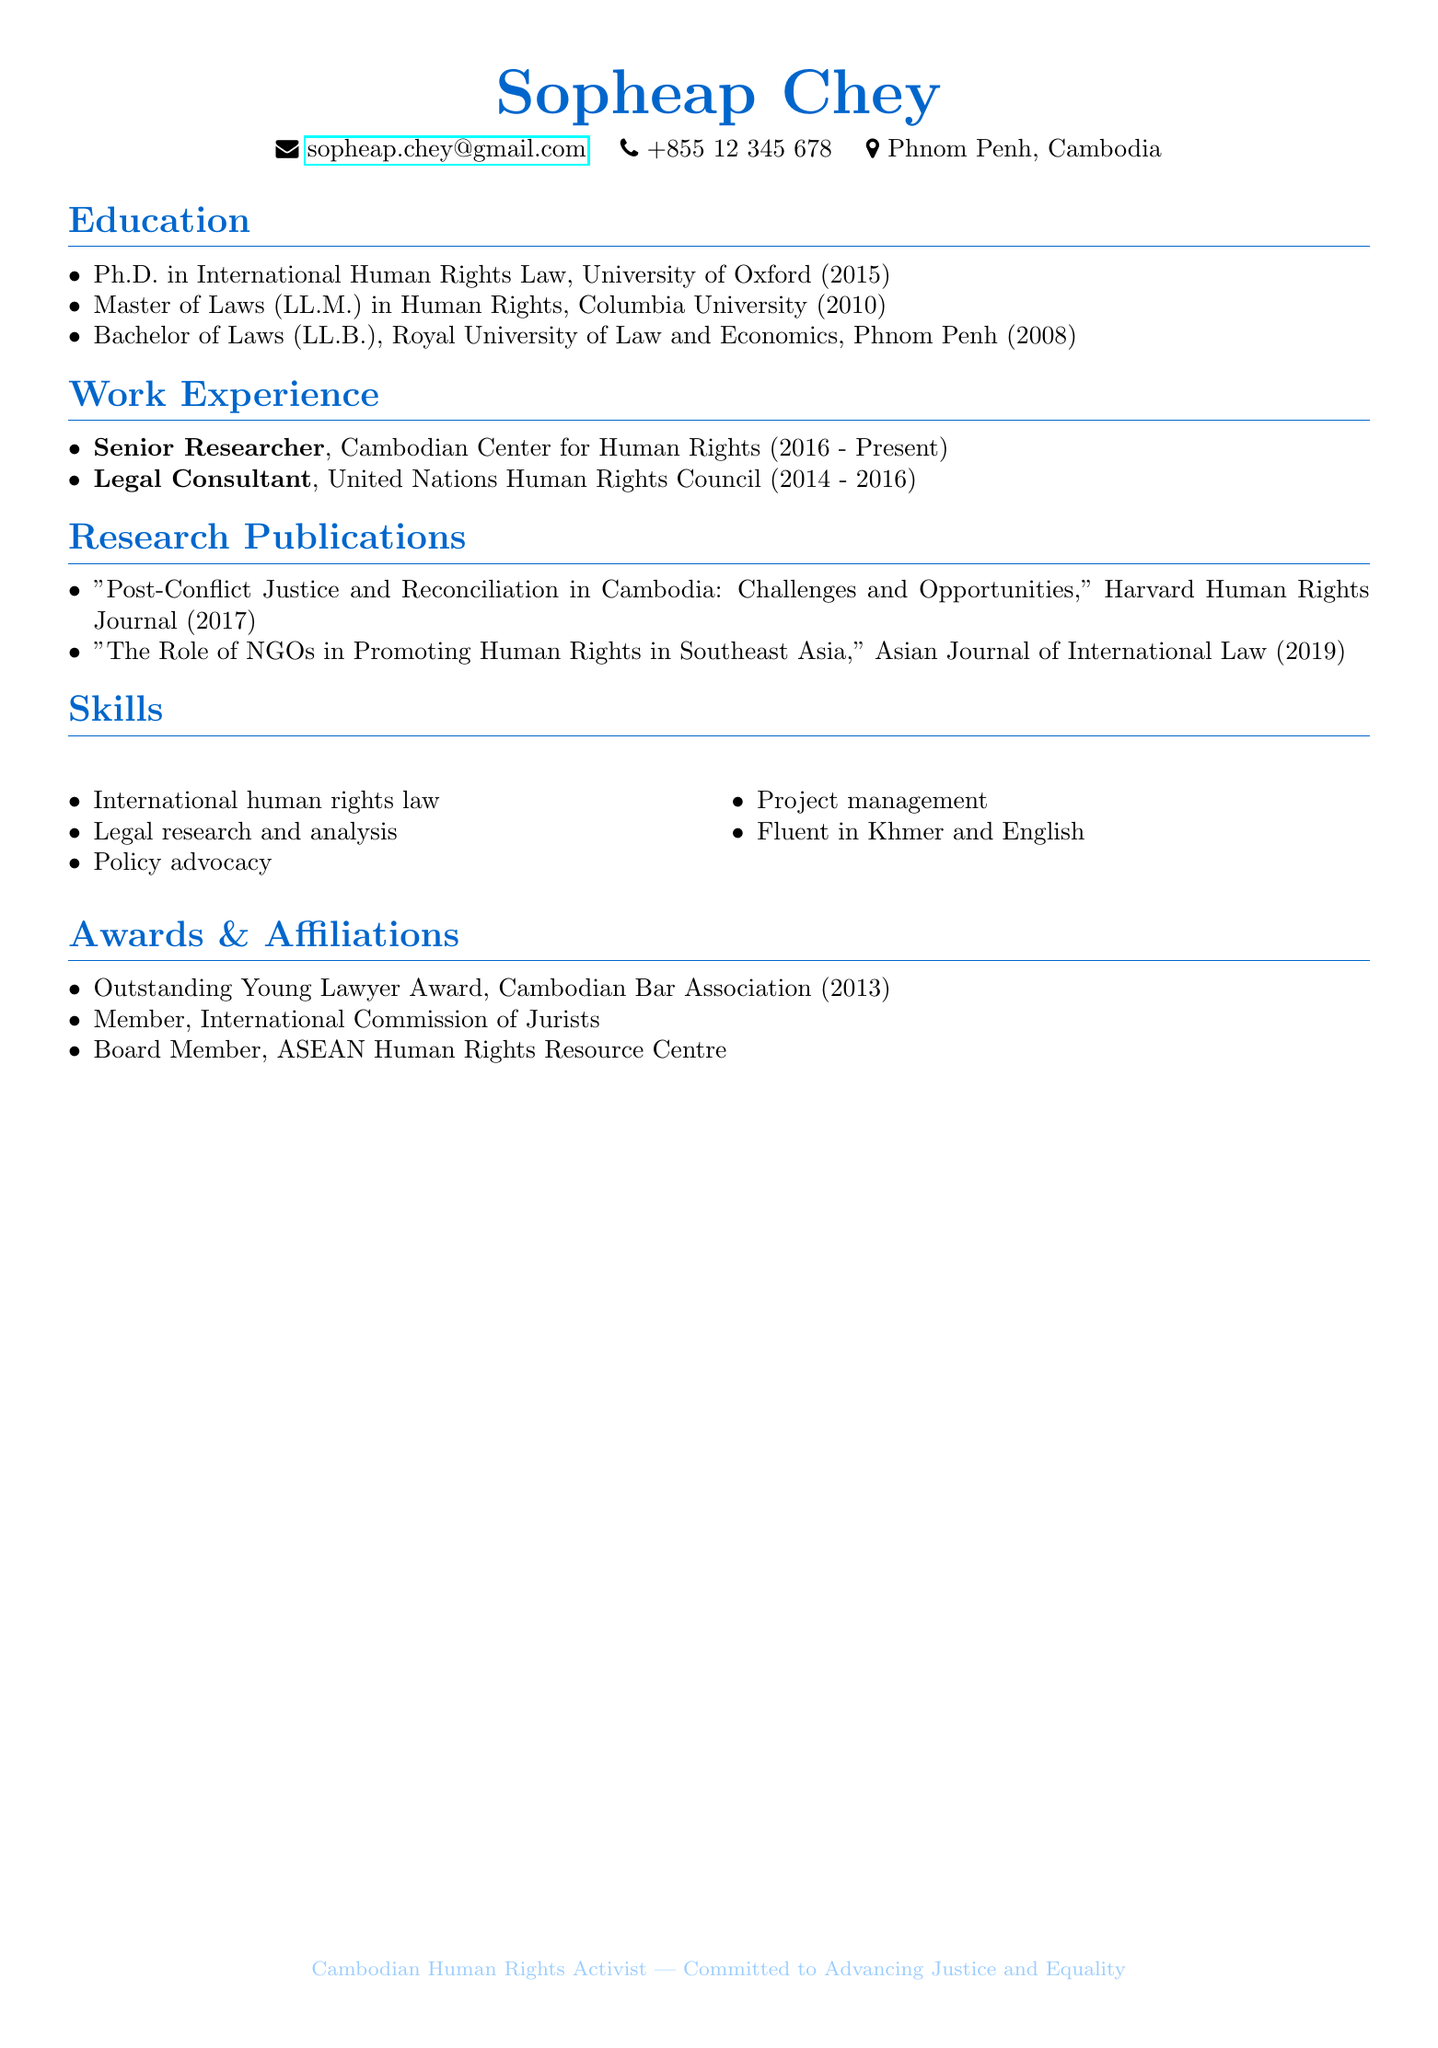What is the highest academic degree attained by Sopheap Chey? The document states that Sopheap Chey holds a Ph.D. in International Human Rights Law, making it the highest academic degree mentioned.
Answer: Ph.D. in International Human Rights Law In which year did Sopheap Chey complete their Master's degree? The document lists the year 2010 as the year Sopheap Chey obtained their Master of Laws (LL.M.) in Human Rights.
Answer: 2010 What position does Sopheap Chey currently hold? The document indicates that Sopheap Chey is a Senior Researcher at the Cambodian Center for Human Rights, which is their current position.
Answer: Senior Researcher Which award did Sopheap Chey receive in 2013? The document highlights the Outstanding Young Lawyer Award from the Cambodian Bar Association as the award received that year.
Answer: Outstanding Young Lawyer Award What are the two languages Sopheap Chey is fluent in? The document specifically mentions that Sopheap Chey is fluent in Khmer and English, indicating the languages spoken.
Answer: Khmer and English What is the title of Sopheap Chey's 2017 research publication? The document lists "Post-Conflict Justice and Reconciliation in Cambodia: Challenges and Opportunities" as the title of the research publication from 2017.
Answer: Post-Conflict Justice and Reconciliation in Cambodia: Challenges and Opportunities How long did Sopheap Chey work as a Legal Consultant? The document states that Sopheap Chey worked as a Legal Consultant at the United Nations Human Rights Council from 2014 to 2016, amounting to a two-year duration.
Answer: 2 years Which organization is Sopheap Chey affiliated with as a board member? The document indicates that Sopheap Chey is a Board Member of the ASEAN Human Rights Resource Centre, describing their affiliation.
Answer: ASEAN Human Rights Resource Centre 